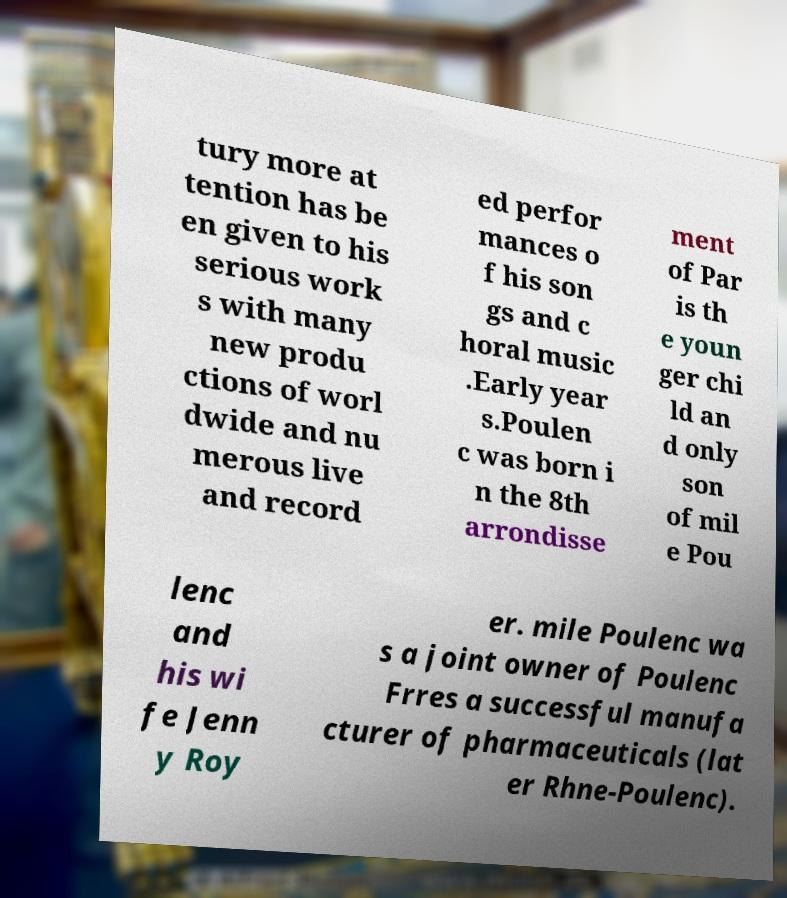For documentation purposes, I need the text within this image transcribed. Could you provide that? tury more at tention has be en given to his serious work s with many new produ ctions of worl dwide and nu merous live and record ed perfor mances o f his son gs and c horal music .Early year s.Poulen c was born i n the 8th arrondisse ment of Par is th e youn ger chi ld an d only son of mil e Pou lenc and his wi fe Jenn y Roy er. mile Poulenc wa s a joint owner of Poulenc Frres a successful manufa cturer of pharmaceuticals (lat er Rhne-Poulenc). 